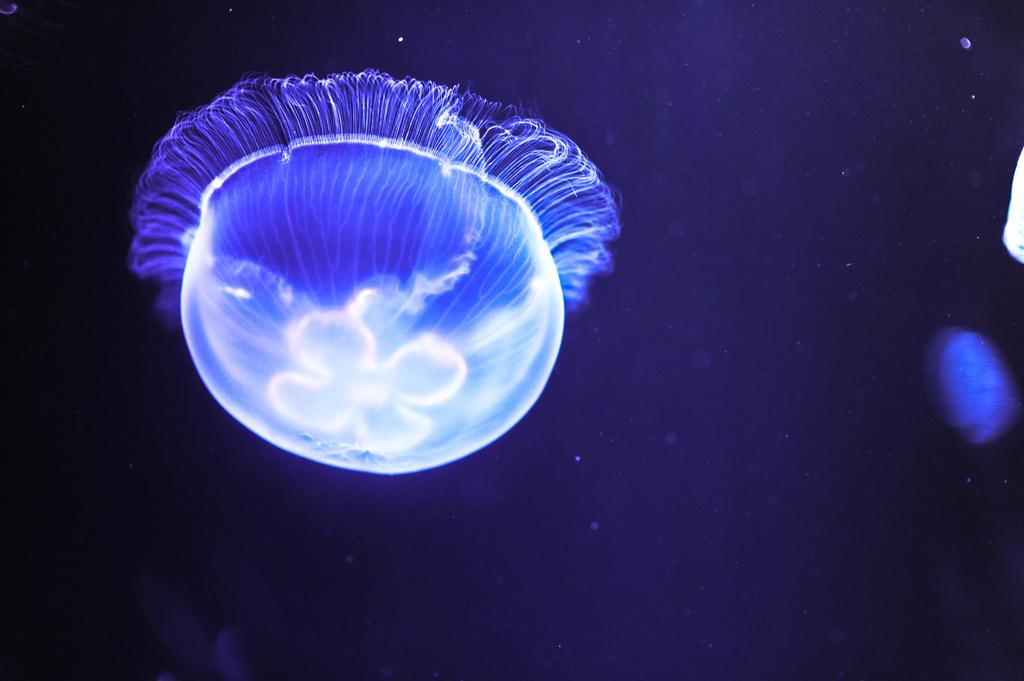What type of sea creature is in the image? There is a jellyfish in the image. What color is the jellyfish? The jellyfish is blue in color. How many silver drops can be seen falling from the jellyfish in the image? There are no silver drops present in the image; it only features a blue jellyfish. 